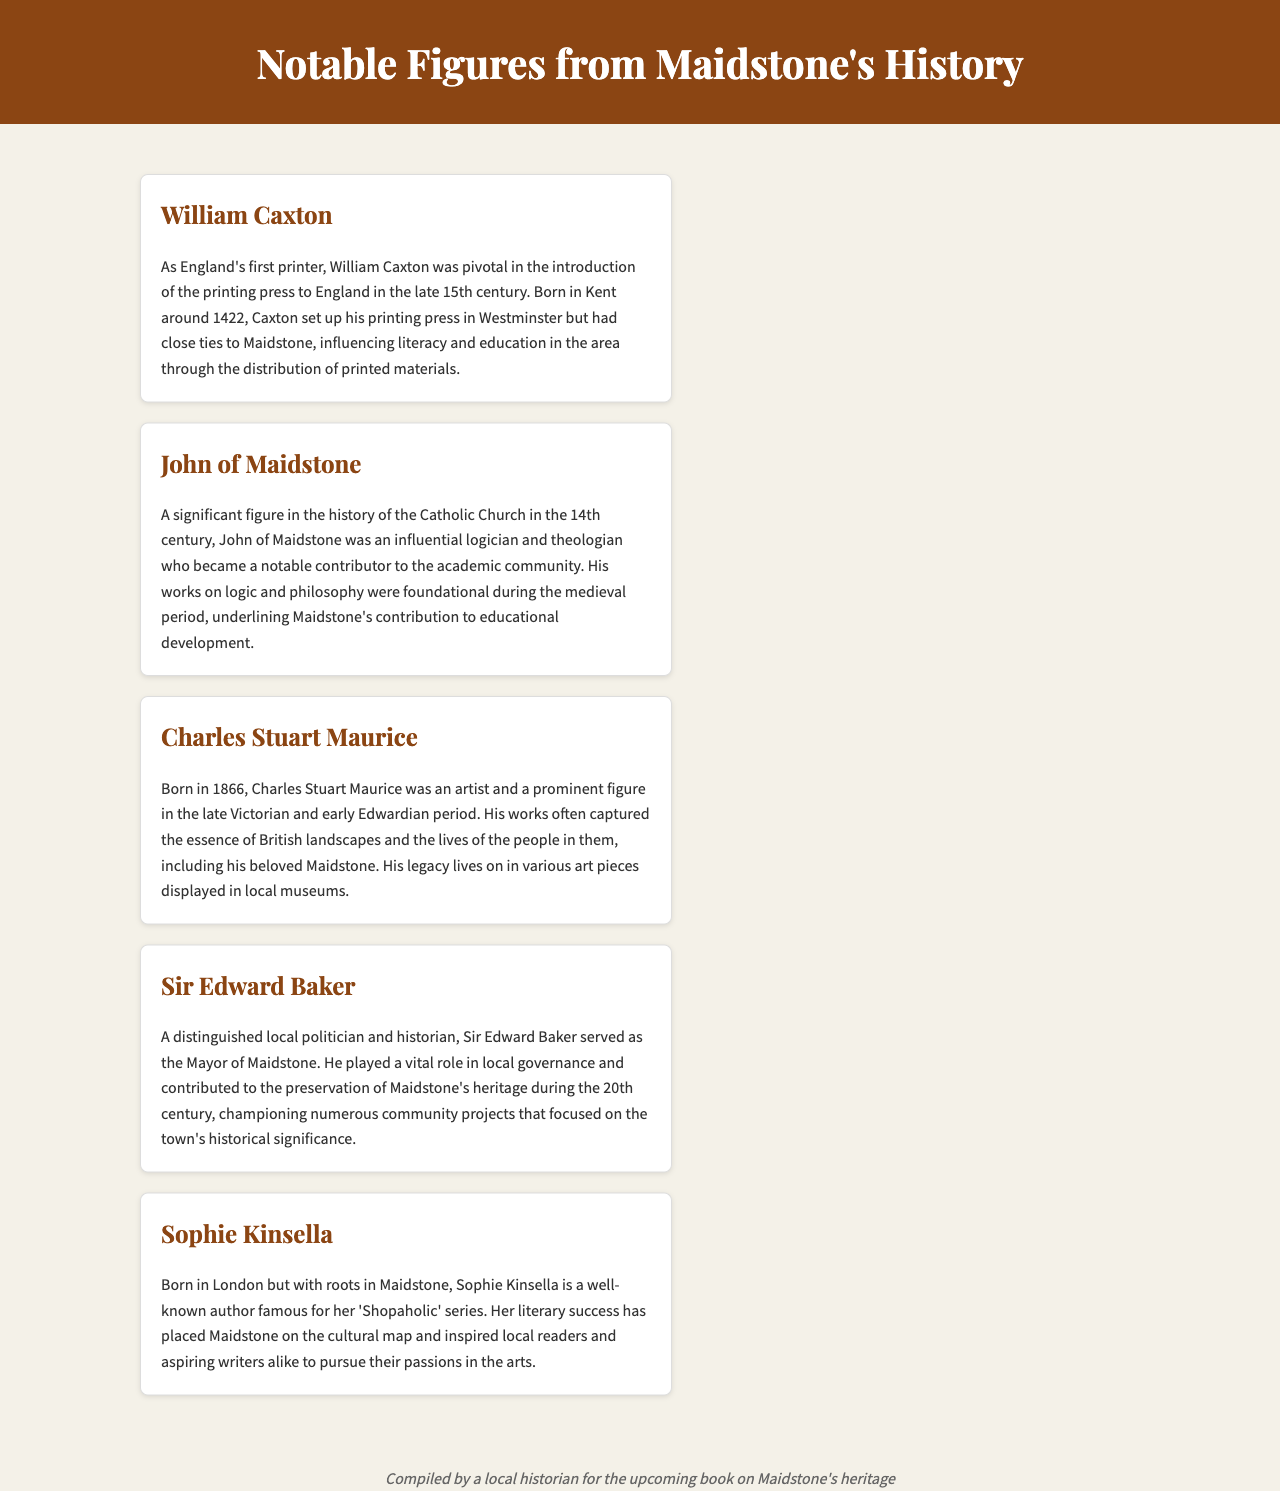what was William Caxton known for? William Caxton was known for being England's first printer and for introducing the printing press to England.
Answer: first printer who was a notable theologian from Maidstone? John of Maidstone is highlighted as a significant logician and theologian who contributed to the academic community in the 14th century.
Answer: John of Maidstone in what year was Charles Stuart Maurice born? The document states that Charles Stuart Maurice was born in 1866.
Answer: 1866 which local politician was a mayor of Maidstone? Sir Edward Baker served as the Mayor of Maidstone and played a vital role in local governance.
Answer: Sir Edward Baker what series is Sophie Kinsella famous for? Sophie Kinsella is famous for her 'Shopaholic' series.
Answer: Shopaholic series how did William Caxton influence literacy? William Caxton influenced literacy and education in Maidstone through the distribution of printed materials.
Answer: distribution of printed materials who contributed to the preservation of Maidstone's heritage? Sir Edward Baker is mentioned as a contributor to the preservation of Maidstone's heritage during the 20th century.
Answer: Sir Edward Baker what is Charles Stuart Maurice's legacy associated with? Charles Stuart Maurice's legacy lives on in various art pieces displayed in local museums.
Answer: art pieces displayed in local museums what common theme is found in the documentation of notable figures? The common theme is their contributions to education, art, and governance in Maidstone's history.
Answer: contributions to education, art, and governance 